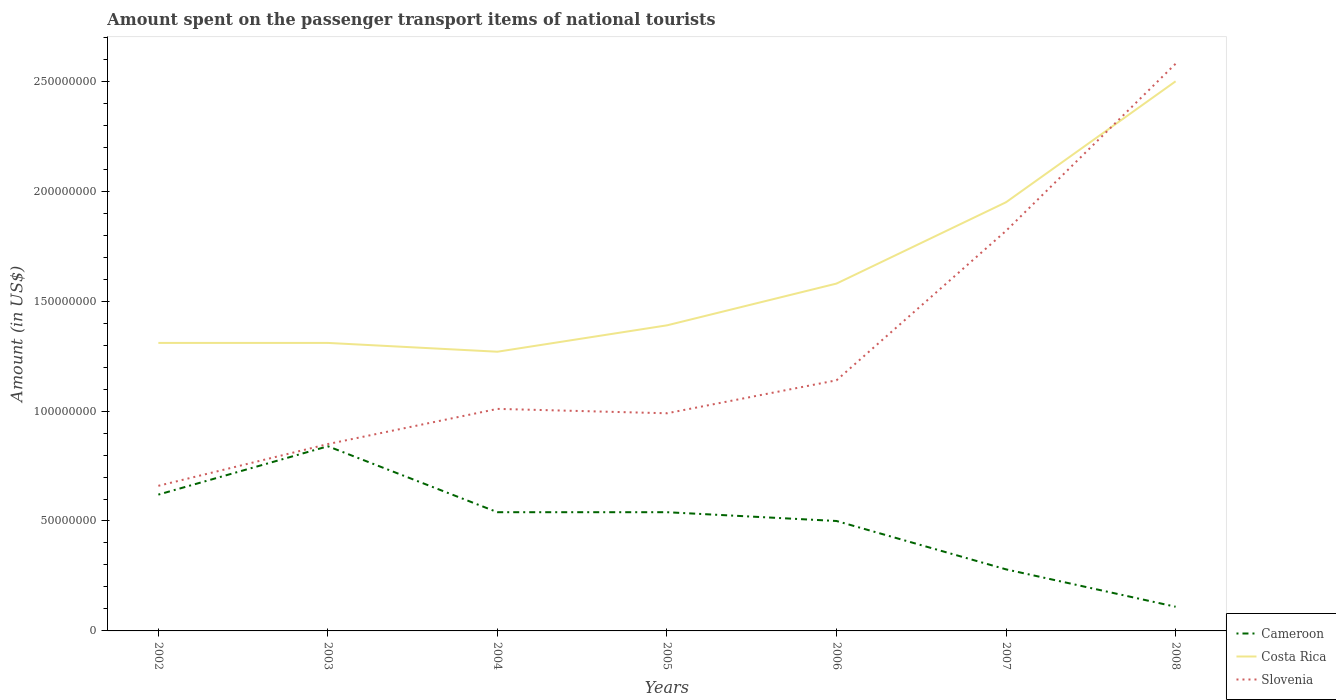How many different coloured lines are there?
Your answer should be very brief. 3. Is the number of lines equal to the number of legend labels?
Keep it short and to the point. Yes. Across all years, what is the maximum amount spent on the passenger transport items of national tourists in Slovenia?
Ensure brevity in your answer.  6.60e+07. What is the total amount spent on the passenger transport items of national tourists in Slovenia in the graph?
Offer a terse response. -1.60e+07. What is the difference between the highest and the second highest amount spent on the passenger transport items of national tourists in Cameroon?
Provide a succinct answer. 7.30e+07. What is the difference between the highest and the lowest amount spent on the passenger transport items of national tourists in Slovenia?
Your answer should be compact. 2. How many lines are there?
Your answer should be compact. 3. Are the values on the major ticks of Y-axis written in scientific E-notation?
Provide a short and direct response. No. Does the graph contain any zero values?
Make the answer very short. No. Does the graph contain grids?
Make the answer very short. No. How many legend labels are there?
Offer a terse response. 3. How are the legend labels stacked?
Give a very brief answer. Vertical. What is the title of the graph?
Make the answer very short. Amount spent on the passenger transport items of national tourists. What is the Amount (in US$) in Cameroon in 2002?
Your answer should be very brief. 6.20e+07. What is the Amount (in US$) of Costa Rica in 2002?
Your response must be concise. 1.31e+08. What is the Amount (in US$) in Slovenia in 2002?
Offer a very short reply. 6.60e+07. What is the Amount (in US$) of Cameroon in 2003?
Offer a terse response. 8.40e+07. What is the Amount (in US$) in Costa Rica in 2003?
Offer a terse response. 1.31e+08. What is the Amount (in US$) of Slovenia in 2003?
Keep it short and to the point. 8.50e+07. What is the Amount (in US$) of Cameroon in 2004?
Make the answer very short. 5.40e+07. What is the Amount (in US$) of Costa Rica in 2004?
Your answer should be very brief. 1.27e+08. What is the Amount (in US$) in Slovenia in 2004?
Offer a terse response. 1.01e+08. What is the Amount (in US$) of Cameroon in 2005?
Your answer should be compact. 5.40e+07. What is the Amount (in US$) in Costa Rica in 2005?
Your response must be concise. 1.39e+08. What is the Amount (in US$) in Slovenia in 2005?
Your response must be concise. 9.90e+07. What is the Amount (in US$) of Costa Rica in 2006?
Make the answer very short. 1.58e+08. What is the Amount (in US$) in Slovenia in 2006?
Your answer should be very brief. 1.14e+08. What is the Amount (in US$) in Cameroon in 2007?
Keep it short and to the point. 2.80e+07. What is the Amount (in US$) in Costa Rica in 2007?
Your answer should be very brief. 1.95e+08. What is the Amount (in US$) of Slovenia in 2007?
Provide a short and direct response. 1.82e+08. What is the Amount (in US$) in Cameroon in 2008?
Your answer should be compact. 1.10e+07. What is the Amount (in US$) of Costa Rica in 2008?
Give a very brief answer. 2.50e+08. What is the Amount (in US$) of Slovenia in 2008?
Your answer should be compact. 2.58e+08. Across all years, what is the maximum Amount (in US$) of Cameroon?
Ensure brevity in your answer.  8.40e+07. Across all years, what is the maximum Amount (in US$) in Costa Rica?
Ensure brevity in your answer.  2.50e+08. Across all years, what is the maximum Amount (in US$) of Slovenia?
Make the answer very short. 2.58e+08. Across all years, what is the minimum Amount (in US$) in Cameroon?
Ensure brevity in your answer.  1.10e+07. Across all years, what is the minimum Amount (in US$) in Costa Rica?
Keep it short and to the point. 1.27e+08. Across all years, what is the minimum Amount (in US$) in Slovenia?
Your answer should be very brief. 6.60e+07. What is the total Amount (in US$) of Cameroon in the graph?
Provide a succinct answer. 3.43e+08. What is the total Amount (in US$) of Costa Rica in the graph?
Provide a short and direct response. 1.13e+09. What is the total Amount (in US$) of Slovenia in the graph?
Your answer should be very brief. 9.05e+08. What is the difference between the Amount (in US$) of Cameroon in 2002 and that in 2003?
Offer a terse response. -2.20e+07. What is the difference between the Amount (in US$) of Costa Rica in 2002 and that in 2003?
Keep it short and to the point. 0. What is the difference between the Amount (in US$) in Slovenia in 2002 and that in 2003?
Make the answer very short. -1.90e+07. What is the difference between the Amount (in US$) of Slovenia in 2002 and that in 2004?
Provide a short and direct response. -3.50e+07. What is the difference between the Amount (in US$) of Cameroon in 2002 and that in 2005?
Keep it short and to the point. 8.00e+06. What is the difference between the Amount (in US$) of Costa Rica in 2002 and that in 2005?
Your response must be concise. -8.00e+06. What is the difference between the Amount (in US$) of Slovenia in 2002 and that in 2005?
Your answer should be very brief. -3.30e+07. What is the difference between the Amount (in US$) of Costa Rica in 2002 and that in 2006?
Offer a terse response. -2.70e+07. What is the difference between the Amount (in US$) of Slovenia in 2002 and that in 2006?
Give a very brief answer. -4.80e+07. What is the difference between the Amount (in US$) of Cameroon in 2002 and that in 2007?
Your answer should be compact. 3.40e+07. What is the difference between the Amount (in US$) in Costa Rica in 2002 and that in 2007?
Provide a succinct answer. -6.40e+07. What is the difference between the Amount (in US$) of Slovenia in 2002 and that in 2007?
Provide a short and direct response. -1.16e+08. What is the difference between the Amount (in US$) of Cameroon in 2002 and that in 2008?
Your answer should be very brief. 5.10e+07. What is the difference between the Amount (in US$) in Costa Rica in 2002 and that in 2008?
Make the answer very short. -1.19e+08. What is the difference between the Amount (in US$) of Slovenia in 2002 and that in 2008?
Offer a very short reply. -1.92e+08. What is the difference between the Amount (in US$) in Cameroon in 2003 and that in 2004?
Keep it short and to the point. 3.00e+07. What is the difference between the Amount (in US$) in Costa Rica in 2003 and that in 2004?
Your answer should be very brief. 4.00e+06. What is the difference between the Amount (in US$) of Slovenia in 2003 and that in 2004?
Your answer should be compact. -1.60e+07. What is the difference between the Amount (in US$) of Cameroon in 2003 and that in 2005?
Provide a succinct answer. 3.00e+07. What is the difference between the Amount (in US$) of Costa Rica in 2003 and that in 2005?
Offer a very short reply. -8.00e+06. What is the difference between the Amount (in US$) of Slovenia in 2003 and that in 2005?
Offer a terse response. -1.40e+07. What is the difference between the Amount (in US$) in Cameroon in 2003 and that in 2006?
Provide a short and direct response. 3.40e+07. What is the difference between the Amount (in US$) of Costa Rica in 2003 and that in 2006?
Provide a succinct answer. -2.70e+07. What is the difference between the Amount (in US$) of Slovenia in 2003 and that in 2006?
Your response must be concise. -2.90e+07. What is the difference between the Amount (in US$) of Cameroon in 2003 and that in 2007?
Provide a short and direct response. 5.60e+07. What is the difference between the Amount (in US$) in Costa Rica in 2003 and that in 2007?
Provide a short and direct response. -6.40e+07. What is the difference between the Amount (in US$) in Slovenia in 2003 and that in 2007?
Give a very brief answer. -9.70e+07. What is the difference between the Amount (in US$) in Cameroon in 2003 and that in 2008?
Your answer should be very brief. 7.30e+07. What is the difference between the Amount (in US$) in Costa Rica in 2003 and that in 2008?
Offer a very short reply. -1.19e+08. What is the difference between the Amount (in US$) in Slovenia in 2003 and that in 2008?
Your answer should be very brief. -1.73e+08. What is the difference between the Amount (in US$) in Costa Rica in 2004 and that in 2005?
Offer a very short reply. -1.20e+07. What is the difference between the Amount (in US$) in Cameroon in 2004 and that in 2006?
Keep it short and to the point. 4.00e+06. What is the difference between the Amount (in US$) in Costa Rica in 2004 and that in 2006?
Give a very brief answer. -3.10e+07. What is the difference between the Amount (in US$) in Slovenia in 2004 and that in 2006?
Keep it short and to the point. -1.30e+07. What is the difference between the Amount (in US$) of Cameroon in 2004 and that in 2007?
Provide a succinct answer. 2.60e+07. What is the difference between the Amount (in US$) in Costa Rica in 2004 and that in 2007?
Your answer should be very brief. -6.80e+07. What is the difference between the Amount (in US$) of Slovenia in 2004 and that in 2007?
Your response must be concise. -8.10e+07. What is the difference between the Amount (in US$) of Cameroon in 2004 and that in 2008?
Offer a very short reply. 4.30e+07. What is the difference between the Amount (in US$) in Costa Rica in 2004 and that in 2008?
Your response must be concise. -1.23e+08. What is the difference between the Amount (in US$) of Slovenia in 2004 and that in 2008?
Provide a short and direct response. -1.57e+08. What is the difference between the Amount (in US$) of Costa Rica in 2005 and that in 2006?
Provide a short and direct response. -1.90e+07. What is the difference between the Amount (in US$) in Slovenia in 2005 and that in 2006?
Ensure brevity in your answer.  -1.50e+07. What is the difference between the Amount (in US$) of Cameroon in 2005 and that in 2007?
Keep it short and to the point. 2.60e+07. What is the difference between the Amount (in US$) of Costa Rica in 2005 and that in 2007?
Offer a terse response. -5.60e+07. What is the difference between the Amount (in US$) in Slovenia in 2005 and that in 2007?
Your answer should be compact. -8.30e+07. What is the difference between the Amount (in US$) in Cameroon in 2005 and that in 2008?
Keep it short and to the point. 4.30e+07. What is the difference between the Amount (in US$) in Costa Rica in 2005 and that in 2008?
Offer a terse response. -1.11e+08. What is the difference between the Amount (in US$) in Slovenia in 2005 and that in 2008?
Offer a very short reply. -1.59e+08. What is the difference between the Amount (in US$) in Cameroon in 2006 and that in 2007?
Your answer should be very brief. 2.20e+07. What is the difference between the Amount (in US$) in Costa Rica in 2006 and that in 2007?
Keep it short and to the point. -3.70e+07. What is the difference between the Amount (in US$) of Slovenia in 2006 and that in 2007?
Give a very brief answer. -6.80e+07. What is the difference between the Amount (in US$) of Cameroon in 2006 and that in 2008?
Offer a terse response. 3.90e+07. What is the difference between the Amount (in US$) in Costa Rica in 2006 and that in 2008?
Your answer should be compact. -9.20e+07. What is the difference between the Amount (in US$) of Slovenia in 2006 and that in 2008?
Keep it short and to the point. -1.44e+08. What is the difference between the Amount (in US$) of Cameroon in 2007 and that in 2008?
Your answer should be compact. 1.70e+07. What is the difference between the Amount (in US$) in Costa Rica in 2007 and that in 2008?
Your response must be concise. -5.50e+07. What is the difference between the Amount (in US$) in Slovenia in 2007 and that in 2008?
Keep it short and to the point. -7.60e+07. What is the difference between the Amount (in US$) in Cameroon in 2002 and the Amount (in US$) in Costa Rica in 2003?
Make the answer very short. -6.90e+07. What is the difference between the Amount (in US$) in Cameroon in 2002 and the Amount (in US$) in Slovenia in 2003?
Your answer should be very brief. -2.30e+07. What is the difference between the Amount (in US$) in Costa Rica in 2002 and the Amount (in US$) in Slovenia in 2003?
Your response must be concise. 4.60e+07. What is the difference between the Amount (in US$) in Cameroon in 2002 and the Amount (in US$) in Costa Rica in 2004?
Your answer should be very brief. -6.50e+07. What is the difference between the Amount (in US$) of Cameroon in 2002 and the Amount (in US$) of Slovenia in 2004?
Give a very brief answer. -3.90e+07. What is the difference between the Amount (in US$) in Costa Rica in 2002 and the Amount (in US$) in Slovenia in 2004?
Provide a short and direct response. 3.00e+07. What is the difference between the Amount (in US$) of Cameroon in 2002 and the Amount (in US$) of Costa Rica in 2005?
Keep it short and to the point. -7.70e+07. What is the difference between the Amount (in US$) of Cameroon in 2002 and the Amount (in US$) of Slovenia in 2005?
Make the answer very short. -3.70e+07. What is the difference between the Amount (in US$) of Costa Rica in 2002 and the Amount (in US$) of Slovenia in 2005?
Provide a succinct answer. 3.20e+07. What is the difference between the Amount (in US$) in Cameroon in 2002 and the Amount (in US$) in Costa Rica in 2006?
Ensure brevity in your answer.  -9.60e+07. What is the difference between the Amount (in US$) in Cameroon in 2002 and the Amount (in US$) in Slovenia in 2006?
Make the answer very short. -5.20e+07. What is the difference between the Amount (in US$) of Costa Rica in 2002 and the Amount (in US$) of Slovenia in 2006?
Your response must be concise. 1.70e+07. What is the difference between the Amount (in US$) of Cameroon in 2002 and the Amount (in US$) of Costa Rica in 2007?
Give a very brief answer. -1.33e+08. What is the difference between the Amount (in US$) of Cameroon in 2002 and the Amount (in US$) of Slovenia in 2007?
Offer a very short reply. -1.20e+08. What is the difference between the Amount (in US$) in Costa Rica in 2002 and the Amount (in US$) in Slovenia in 2007?
Give a very brief answer. -5.10e+07. What is the difference between the Amount (in US$) in Cameroon in 2002 and the Amount (in US$) in Costa Rica in 2008?
Keep it short and to the point. -1.88e+08. What is the difference between the Amount (in US$) in Cameroon in 2002 and the Amount (in US$) in Slovenia in 2008?
Offer a terse response. -1.96e+08. What is the difference between the Amount (in US$) of Costa Rica in 2002 and the Amount (in US$) of Slovenia in 2008?
Your answer should be very brief. -1.27e+08. What is the difference between the Amount (in US$) of Cameroon in 2003 and the Amount (in US$) of Costa Rica in 2004?
Your answer should be very brief. -4.30e+07. What is the difference between the Amount (in US$) of Cameroon in 2003 and the Amount (in US$) of Slovenia in 2004?
Offer a terse response. -1.70e+07. What is the difference between the Amount (in US$) of Costa Rica in 2003 and the Amount (in US$) of Slovenia in 2004?
Offer a very short reply. 3.00e+07. What is the difference between the Amount (in US$) of Cameroon in 2003 and the Amount (in US$) of Costa Rica in 2005?
Give a very brief answer. -5.50e+07. What is the difference between the Amount (in US$) in Cameroon in 2003 and the Amount (in US$) in Slovenia in 2005?
Offer a very short reply. -1.50e+07. What is the difference between the Amount (in US$) of Costa Rica in 2003 and the Amount (in US$) of Slovenia in 2005?
Provide a succinct answer. 3.20e+07. What is the difference between the Amount (in US$) in Cameroon in 2003 and the Amount (in US$) in Costa Rica in 2006?
Your answer should be very brief. -7.40e+07. What is the difference between the Amount (in US$) in Cameroon in 2003 and the Amount (in US$) in Slovenia in 2006?
Your response must be concise. -3.00e+07. What is the difference between the Amount (in US$) in Costa Rica in 2003 and the Amount (in US$) in Slovenia in 2006?
Offer a terse response. 1.70e+07. What is the difference between the Amount (in US$) of Cameroon in 2003 and the Amount (in US$) of Costa Rica in 2007?
Give a very brief answer. -1.11e+08. What is the difference between the Amount (in US$) of Cameroon in 2003 and the Amount (in US$) of Slovenia in 2007?
Give a very brief answer. -9.80e+07. What is the difference between the Amount (in US$) of Costa Rica in 2003 and the Amount (in US$) of Slovenia in 2007?
Your response must be concise. -5.10e+07. What is the difference between the Amount (in US$) of Cameroon in 2003 and the Amount (in US$) of Costa Rica in 2008?
Provide a short and direct response. -1.66e+08. What is the difference between the Amount (in US$) of Cameroon in 2003 and the Amount (in US$) of Slovenia in 2008?
Make the answer very short. -1.74e+08. What is the difference between the Amount (in US$) of Costa Rica in 2003 and the Amount (in US$) of Slovenia in 2008?
Make the answer very short. -1.27e+08. What is the difference between the Amount (in US$) of Cameroon in 2004 and the Amount (in US$) of Costa Rica in 2005?
Give a very brief answer. -8.50e+07. What is the difference between the Amount (in US$) of Cameroon in 2004 and the Amount (in US$) of Slovenia in 2005?
Offer a very short reply. -4.50e+07. What is the difference between the Amount (in US$) in Costa Rica in 2004 and the Amount (in US$) in Slovenia in 2005?
Offer a very short reply. 2.80e+07. What is the difference between the Amount (in US$) of Cameroon in 2004 and the Amount (in US$) of Costa Rica in 2006?
Keep it short and to the point. -1.04e+08. What is the difference between the Amount (in US$) of Cameroon in 2004 and the Amount (in US$) of Slovenia in 2006?
Provide a succinct answer. -6.00e+07. What is the difference between the Amount (in US$) of Costa Rica in 2004 and the Amount (in US$) of Slovenia in 2006?
Make the answer very short. 1.30e+07. What is the difference between the Amount (in US$) in Cameroon in 2004 and the Amount (in US$) in Costa Rica in 2007?
Offer a terse response. -1.41e+08. What is the difference between the Amount (in US$) of Cameroon in 2004 and the Amount (in US$) of Slovenia in 2007?
Provide a succinct answer. -1.28e+08. What is the difference between the Amount (in US$) of Costa Rica in 2004 and the Amount (in US$) of Slovenia in 2007?
Offer a terse response. -5.50e+07. What is the difference between the Amount (in US$) of Cameroon in 2004 and the Amount (in US$) of Costa Rica in 2008?
Your answer should be very brief. -1.96e+08. What is the difference between the Amount (in US$) of Cameroon in 2004 and the Amount (in US$) of Slovenia in 2008?
Provide a short and direct response. -2.04e+08. What is the difference between the Amount (in US$) of Costa Rica in 2004 and the Amount (in US$) of Slovenia in 2008?
Make the answer very short. -1.31e+08. What is the difference between the Amount (in US$) of Cameroon in 2005 and the Amount (in US$) of Costa Rica in 2006?
Offer a terse response. -1.04e+08. What is the difference between the Amount (in US$) of Cameroon in 2005 and the Amount (in US$) of Slovenia in 2006?
Make the answer very short. -6.00e+07. What is the difference between the Amount (in US$) of Costa Rica in 2005 and the Amount (in US$) of Slovenia in 2006?
Keep it short and to the point. 2.50e+07. What is the difference between the Amount (in US$) in Cameroon in 2005 and the Amount (in US$) in Costa Rica in 2007?
Offer a terse response. -1.41e+08. What is the difference between the Amount (in US$) in Cameroon in 2005 and the Amount (in US$) in Slovenia in 2007?
Give a very brief answer. -1.28e+08. What is the difference between the Amount (in US$) of Costa Rica in 2005 and the Amount (in US$) of Slovenia in 2007?
Ensure brevity in your answer.  -4.30e+07. What is the difference between the Amount (in US$) of Cameroon in 2005 and the Amount (in US$) of Costa Rica in 2008?
Your answer should be compact. -1.96e+08. What is the difference between the Amount (in US$) in Cameroon in 2005 and the Amount (in US$) in Slovenia in 2008?
Provide a succinct answer. -2.04e+08. What is the difference between the Amount (in US$) of Costa Rica in 2005 and the Amount (in US$) of Slovenia in 2008?
Your response must be concise. -1.19e+08. What is the difference between the Amount (in US$) of Cameroon in 2006 and the Amount (in US$) of Costa Rica in 2007?
Make the answer very short. -1.45e+08. What is the difference between the Amount (in US$) in Cameroon in 2006 and the Amount (in US$) in Slovenia in 2007?
Your response must be concise. -1.32e+08. What is the difference between the Amount (in US$) in Costa Rica in 2006 and the Amount (in US$) in Slovenia in 2007?
Make the answer very short. -2.40e+07. What is the difference between the Amount (in US$) of Cameroon in 2006 and the Amount (in US$) of Costa Rica in 2008?
Provide a short and direct response. -2.00e+08. What is the difference between the Amount (in US$) of Cameroon in 2006 and the Amount (in US$) of Slovenia in 2008?
Make the answer very short. -2.08e+08. What is the difference between the Amount (in US$) in Costa Rica in 2006 and the Amount (in US$) in Slovenia in 2008?
Offer a very short reply. -1.00e+08. What is the difference between the Amount (in US$) in Cameroon in 2007 and the Amount (in US$) in Costa Rica in 2008?
Provide a succinct answer. -2.22e+08. What is the difference between the Amount (in US$) of Cameroon in 2007 and the Amount (in US$) of Slovenia in 2008?
Make the answer very short. -2.30e+08. What is the difference between the Amount (in US$) in Costa Rica in 2007 and the Amount (in US$) in Slovenia in 2008?
Provide a short and direct response. -6.30e+07. What is the average Amount (in US$) of Cameroon per year?
Ensure brevity in your answer.  4.90e+07. What is the average Amount (in US$) of Costa Rica per year?
Provide a succinct answer. 1.62e+08. What is the average Amount (in US$) of Slovenia per year?
Offer a terse response. 1.29e+08. In the year 2002, what is the difference between the Amount (in US$) in Cameroon and Amount (in US$) in Costa Rica?
Offer a very short reply. -6.90e+07. In the year 2002, what is the difference between the Amount (in US$) in Costa Rica and Amount (in US$) in Slovenia?
Your response must be concise. 6.50e+07. In the year 2003, what is the difference between the Amount (in US$) in Cameroon and Amount (in US$) in Costa Rica?
Your answer should be compact. -4.70e+07. In the year 2003, what is the difference between the Amount (in US$) in Cameroon and Amount (in US$) in Slovenia?
Give a very brief answer. -1.00e+06. In the year 2003, what is the difference between the Amount (in US$) in Costa Rica and Amount (in US$) in Slovenia?
Your response must be concise. 4.60e+07. In the year 2004, what is the difference between the Amount (in US$) of Cameroon and Amount (in US$) of Costa Rica?
Provide a short and direct response. -7.30e+07. In the year 2004, what is the difference between the Amount (in US$) of Cameroon and Amount (in US$) of Slovenia?
Provide a short and direct response. -4.70e+07. In the year 2004, what is the difference between the Amount (in US$) of Costa Rica and Amount (in US$) of Slovenia?
Make the answer very short. 2.60e+07. In the year 2005, what is the difference between the Amount (in US$) of Cameroon and Amount (in US$) of Costa Rica?
Your answer should be very brief. -8.50e+07. In the year 2005, what is the difference between the Amount (in US$) in Cameroon and Amount (in US$) in Slovenia?
Provide a succinct answer. -4.50e+07. In the year 2005, what is the difference between the Amount (in US$) of Costa Rica and Amount (in US$) of Slovenia?
Your answer should be compact. 4.00e+07. In the year 2006, what is the difference between the Amount (in US$) of Cameroon and Amount (in US$) of Costa Rica?
Ensure brevity in your answer.  -1.08e+08. In the year 2006, what is the difference between the Amount (in US$) in Cameroon and Amount (in US$) in Slovenia?
Your answer should be very brief. -6.40e+07. In the year 2006, what is the difference between the Amount (in US$) of Costa Rica and Amount (in US$) of Slovenia?
Offer a terse response. 4.40e+07. In the year 2007, what is the difference between the Amount (in US$) in Cameroon and Amount (in US$) in Costa Rica?
Ensure brevity in your answer.  -1.67e+08. In the year 2007, what is the difference between the Amount (in US$) of Cameroon and Amount (in US$) of Slovenia?
Make the answer very short. -1.54e+08. In the year 2007, what is the difference between the Amount (in US$) in Costa Rica and Amount (in US$) in Slovenia?
Keep it short and to the point. 1.30e+07. In the year 2008, what is the difference between the Amount (in US$) in Cameroon and Amount (in US$) in Costa Rica?
Your response must be concise. -2.39e+08. In the year 2008, what is the difference between the Amount (in US$) in Cameroon and Amount (in US$) in Slovenia?
Your answer should be compact. -2.47e+08. In the year 2008, what is the difference between the Amount (in US$) of Costa Rica and Amount (in US$) of Slovenia?
Give a very brief answer. -8.00e+06. What is the ratio of the Amount (in US$) in Cameroon in 2002 to that in 2003?
Ensure brevity in your answer.  0.74. What is the ratio of the Amount (in US$) of Slovenia in 2002 to that in 2003?
Offer a very short reply. 0.78. What is the ratio of the Amount (in US$) of Cameroon in 2002 to that in 2004?
Offer a very short reply. 1.15. What is the ratio of the Amount (in US$) in Costa Rica in 2002 to that in 2004?
Ensure brevity in your answer.  1.03. What is the ratio of the Amount (in US$) of Slovenia in 2002 to that in 2004?
Offer a very short reply. 0.65. What is the ratio of the Amount (in US$) in Cameroon in 2002 to that in 2005?
Make the answer very short. 1.15. What is the ratio of the Amount (in US$) of Costa Rica in 2002 to that in 2005?
Offer a very short reply. 0.94. What is the ratio of the Amount (in US$) in Cameroon in 2002 to that in 2006?
Make the answer very short. 1.24. What is the ratio of the Amount (in US$) in Costa Rica in 2002 to that in 2006?
Offer a very short reply. 0.83. What is the ratio of the Amount (in US$) in Slovenia in 2002 to that in 2006?
Offer a very short reply. 0.58. What is the ratio of the Amount (in US$) in Cameroon in 2002 to that in 2007?
Offer a terse response. 2.21. What is the ratio of the Amount (in US$) in Costa Rica in 2002 to that in 2007?
Give a very brief answer. 0.67. What is the ratio of the Amount (in US$) in Slovenia in 2002 to that in 2007?
Keep it short and to the point. 0.36. What is the ratio of the Amount (in US$) of Cameroon in 2002 to that in 2008?
Provide a succinct answer. 5.64. What is the ratio of the Amount (in US$) in Costa Rica in 2002 to that in 2008?
Your response must be concise. 0.52. What is the ratio of the Amount (in US$) in Slovenia in 2002 to that in 2008?
Offer a terse response. 0.26. What is the ratio of the Amount (in US$) of Cameroon in 2003 to that in 2004?
Your answer should be compact. 1.56. What is the ratio of the Amount (in US$) in Costa Rica in 2003 to that in 2004?
Your answer should be compact. 1.03. What is the ratio of the Amount (in US$) in Slovenia in 2003 to that in 2004?
Give a very brief answer. 0.84. What is the ratio of the Amount (in US$) in Cameroon in 2003 to that in 2005?
Your response must be concise. 1.56. What is the ratio of the Amount (in US$) in Costa Rica in 2003 to that in 2005?
Ensure brevity in your answer.  0.94. What is the ratio of the Amount (in US$) in Slovenia in 2003 to that in 2005?
Your answer should be compact. 0.86. What is the ratio of the Amount (in US$) of Cameroon in 2003 to that in 2006?
Your response must be concise. 1.68. What is the ratio of the Amount (in US$) of Costa Rica in 2003 to that in 2006?
Make the answer very short. 0.83. What is the ratio of the Amount (in US$) of Slovenia in 2003 to that in 2006?
Your response must be concise. 0.75. What is the ratio of the Amount (in US$) in Costa Rica in 2003 to that in 2007?
Make the answer very short. 0.67. What is the ratio of the Amount (in US$) of Slovenia in 2003 to that in 2007?
Your answer should be very brief. 0.47. What is the ratio of the Amount (in US$) in Cameroon in 2003 to that in 2008?
Provide a short and direct response. 7.64. What is the ratio of the Amount (in US$) of Costa Rica in 2003 to that in 2008?
Your response must be concise. 0.52. What is the ratio of the Amount (in US$) of Slovenia in 2003 to that in 2008?
Provide a short and direct response. 0.33. What is the ratio of the Amount (in US$) of Costa Rica in 2004 to that in 2005?
Give a very brief answer. 0.91. What is the ratio of the Amount (in US$) in Slovenia in 2004 to that in 2005?
Make the answer very short. 1.02. What is the ratio of the Amount (in US$) in Costa Rica in 2004 to that in 2006?
Offer a terse response. 0.8. What is the ratio of the Amount (in US$) of Slovenia in 2004 to that in 2006?
Give a very brief answer. 0.89. What is the ratio of the Amount (in US$) of Cameroon in 2004 to that in 2007?
Give a very brief answer. 1.93. What is the ratio of the Amount (in US$) in Costa Rica in 2004 to that in 2007?
Provide a short and direct response. 0.65. What is the ratio of the Amount (in US$) in Slovenia in 2004 to that in 2007?
Offer a very short reply. 0.55. What is the ratio of the Amount (in US$) of Cameroon in 2004 to that in 2008?
Offer a very short reply. 4.91. What is the ratio of the Amount (in US$) of Costa Rica in 2004 to that in 2008?
Your response must be concise. 0.51. What is the ratio of the Amount (in US$) of Slovenia in 2004 to that in 2008?
Your answer should be very brief. 0.39. What is the ratio of the Amount (in US$) of Costa Rica in 2005 to that in 2006?
Offer a terse response. 0.88. What is the ratio of the Amount (in US$) of Slovenia in 2005 to that in 2006?
Ensure brevity in your answer.  0.87. What is the ratio of the Amount (in US$) in Cameroon in 2005 to that in 2007?
Offer a terse response. 1.93. What is the ratio of the Amount (in US$) in Costa Rica in 2005 to that in 2007?
Ensure brevity in your answer.  0.71. What is the ratio of the Amount (in US$) of Slovenia in 2005 to that in 2007?
Your response must be concise. 0.54. What is the ratio of the Amount (in US$) in Cameroon in 2005 to that in 2008?
Provide a succinct answer. 4.91. What is the ratio of the Amount (in US$) of Costa Rica in 2005 to that in 2008?
Offer a terse response. 0.56. What is the ratio of the Amount (in US$) in Slovenia in 2005 to that in 2008?
Keep it short and to the point. 0.38. What is the ratio of the Amount (in US$) in Cameroon in 2006 to that in 2007?
Offer a very short reply. 1.79. What is the ratio of the Amount (in US$) in Costa Rica in 2006 to that in 2007?
Provide a succinct answer. 0.81. What is the ratio of the Amount (in US$) in Slovenia in 2006 to that in 2007?
Offer a terse response. 0.63. What is the ratio of the Amount (in US$) in Cameroon in 2006 to that in 2008?
Your answer should be compact. 4.55. What is the ratio of the Amount (in US$) in Costa Rica in 2006 to that in 2008?
Your response must be concise. 0.63. What is the ratio of the Amount (in US$) of Slovenia in 2006 to that in 2008?
Offer a terse response. 0.44. What is the ratio of the Amount (in US$) in Cameroon in 2007 to that in 2008?
Offer a terse response. 2.55. What is the ratio of the Amount (in US$) of Costa Rica in 2007 to that in 2008?
Keep it short and to the point. 0.78. What is the ratio of the Amount (in US$) in Slovenia in 2007 to that in 2008?
Give a very brief answer. 0.71. What is the difference between the highest and the second highest Amount (in US$) of Cameroon?
Your answer should be very brief. 2.20e+07. What is the difference between the highest and the second highest Amount (in US$) of Costa Rica?
Offer a terse response. 5.50e+07. What is the difference between the highest and the second highest Amount (in US$) of Slovenia?
Provide a short and direct response. 7.60e+07. What is the difference between the highest and the lowest Amount (in US$) in Cameroon?
Ensure brevity in your answer.  7.30e+07. What is the difference between the highest and the lowest Amount (in US$) of Costa Rica?
Your response must be concise. 1.23e+08. What is the difference between the highest and the lowest Amount (in US$) in Slovenia?
Provide a short and direct response. 1.92e+08. 